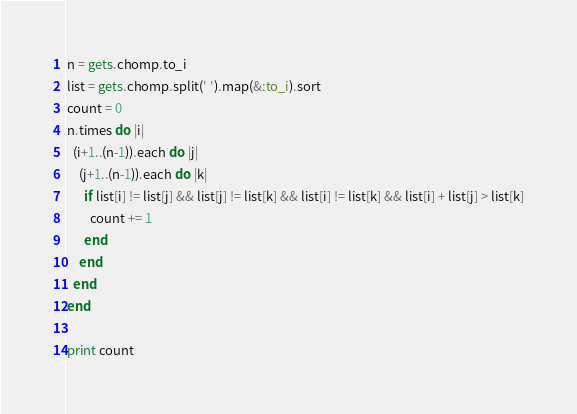<code> <loc_0><loc_0><loc_500><loc_500><_Ruby_>n = gets.chomp.to_i
list = gets.chomp.split(' ').map(&:to_i).sort
count = 0
n.times do |i|
  (i+1..(n-1)).each do |j|
    (j+1..(n-1)).each do |k|
      if list[i] != list[j] && list[j] != list[k] && list[i] != list[k] && list[i] + list[j] > list[k]
        count += 1
      end
    end
  end
end

print count</code> 